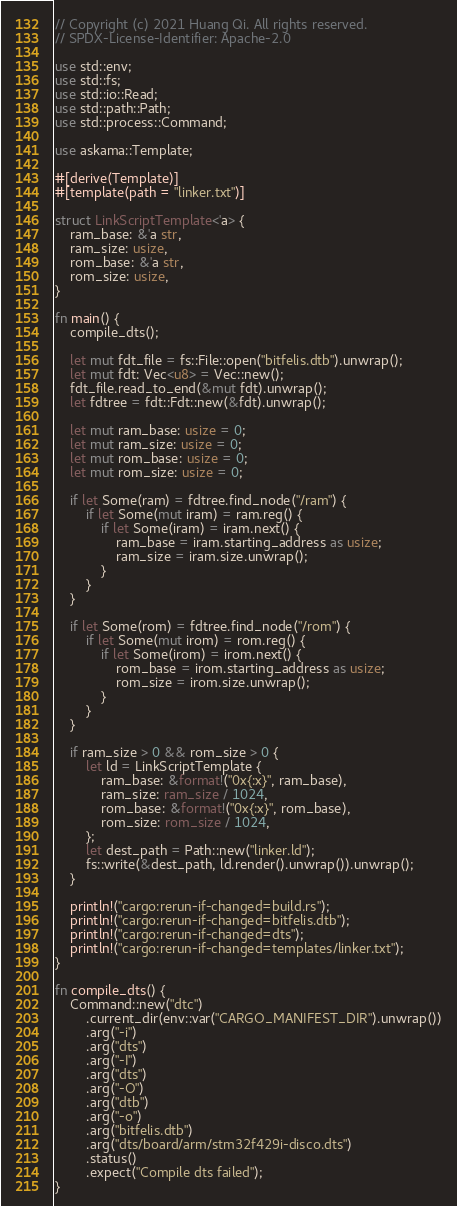<code> <loc_0><loc_0><loc_500><loc_500><_Rust_>// Copyright (c) 2021 Huang Qi. All rights reserved.
// SPDX-License-Identifier: Apache-2.0

use std::env;
use std::fs;
use std::io::Read;
use std::path::Path;
use std::process::Command;

use askama::Template;

#[derive(Template)]
#[template(path = "linker.txt")]

struct LinkScriptTemplate<'a> {
    ram_base: &'a str,
    ram_size: usize,
    rom_base: &'a str,
    rom_size: usize,
}

fn main() {
    compile_dts();

    let mut fdt_file = fs::File::open("bitfelis.dtb").unwrap();
    let mut fdt: Vec<u8> = Vec::new();
    fdt_file.read_to_end(&mut fdt).unwrap();
    let fdtree = fdt::Fdt::new(&fdt).unwrap();

    let mut ram_base: usize = 0;
    let mut ram_size: usize = 0;
    let mut rom_base: usize = 0;
    let mut rom_size: usize = 0;

    if let Some(ram) = fdtree.find_node("/ram") {
        if let Some(mut iram) = ram.reg() {
            if let Some(iram) = iram.next() {
                ram_base = iram.starting_address as usize;
                ram_size = iram.size.unwrap();
            }
        }
    }

    if let Some(rom) = fdtree.find_node("/rom") {
        if let Some(mut irom) = rom.reg() {
            if let Some(irom) = irom.next() {
                rom_base = irom.starting_address as usize;
                rom_size = irom.size.unwrap();
            }
        }
    }

    if ram_size > 0 && rom_size > 0 {
        let ld = LinkScriptTemplate {
            ram_base: &format!("0x{:x}", ram_base),
            ram_size: ram_size / 1024,
            rom_base: &format!("0x{:x}", rom_base),
            rom_size: rom_size / 1024,
        };
        let dest_path = Path::new("linker.ld");
        fs::write(&dest_path, ld.render().unwrap()).unwrap();
    }

    println!("cargo:rerun-if-changed=build.rs");
    println!("cargo:rerun-if-changed=bitfelis.dtb");
    println!("cargo:rerun-if-changed=dts");
    println!("cargo:rerun-if-changed=templates/linker.txt");
}

fn compile_dts() {
    Command::new("dtc")
        .current_dir(env::var("CARGO_MANIFEST_DIR").unwrap())
        .arg("-i")
        .arg("dts")
        .arg("-I")
        .arg("dts")
        .arg("-O")
        .arg("dtb")
        .arg("-o")
        .arg("bitfelis.dtb")
        .arg("dts/board/arm/stm32f429i-disco.dts")
        .status()
        .expect("Compile dts failed");
}
</code> 